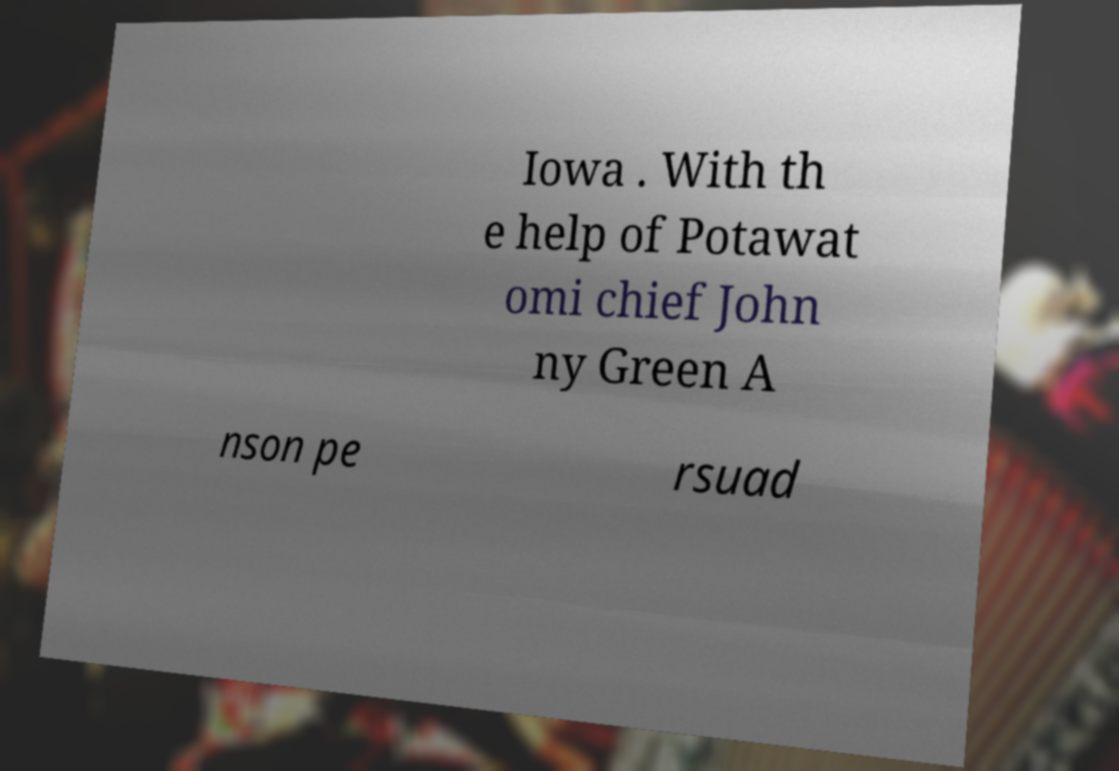Please identify and transcribe the text found in this image. Iowa . With th e help of Potawat omi chief John ny Green A nson pe rsuad 